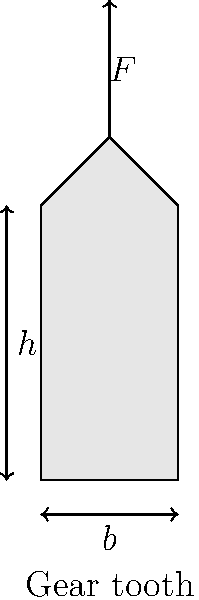As a network equipment provider working with a project manager on a mechanical design aspect, you need to calculate the bending stress on a gear tooth. The gear tooth has a width ($b$) of 20 mm, a height ($h$) of 40 mm, and a thickness ($t$) of 10 mm. A force ($F$) of 1000 N is applied at the tip of the tooth. Calculate the maximum bending stress ($\sigma_{max}$) at the base of the tooth using the formula:

$$\sigma_{max} = \frac{6Fh}{bt^2}$$

Round your answer to the nearest MPa. To calculate the maximum bending stress, we'll use the given formula and substitute the known values:

1. Force ($F$) = 1000 N
2. Height ($h$) = 40 mm = 0.04 m
3. Width ($b$) = 20 mm = 0.02 m
4. Thickness ($t$) = 10 mm = 0.01 m

Now, let's substitute these values into the formula:

$$\sigma_{max} = \frac{6Fh}{bt^2}$$

$$\sigma_{max} = \frac{6 \times 1000 \text{ N} \times 0.04 \text{ m}}{0.02 \text{ m} \times (0.01 \text{ m})^2}$$

$$\sigma_{max} = \frac{240}{0.000002}$$

$$\sigma_{max} = 120,000,000 \text{ Pa} = 120 \text{ MPa}$$

The maximum bending stress at the base of the gear tooth is 120 MPa.
Answer: 120 MPa 